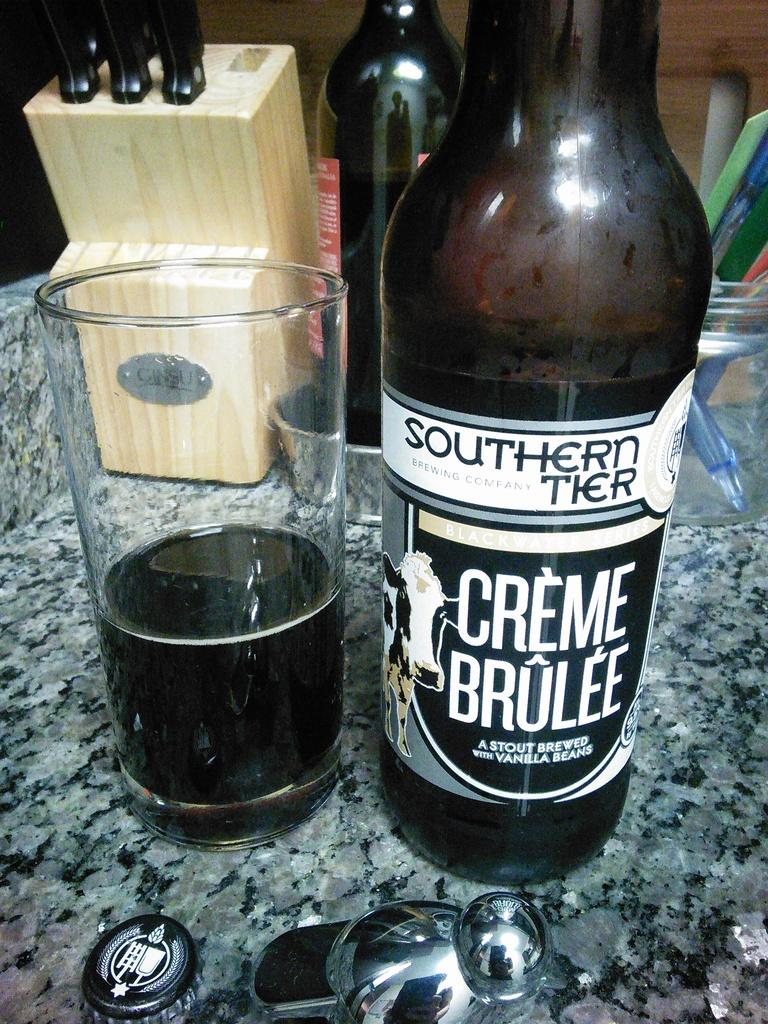<image>
Describe the image concisely. A bottle of Southern Tier Creme Brulee is on a countertop next to a half full glass. 